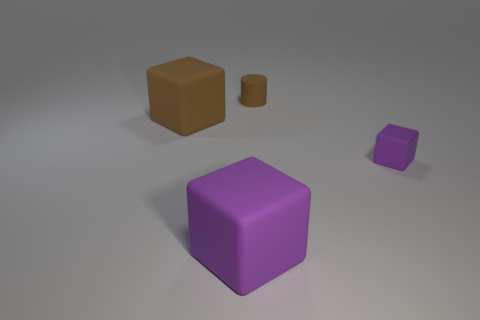What number of purple rubber things are on the left side of the tiny brown rubber cylinder?
Your response must be concise. 1. What number of other things are the same color as the tiny cube?
Offer a terse response. 1. Are there fewer tiny rubber things in front of the large purple object than tiny brown rubber cylinders behind the brown matte block?
Provide a succinct answer. Yes. How many things are either blocks that are right of the small brown thing or big cubes?
Provide a succinct answer. 3. There is a brown matte cylinder; is it the same size as the cube that is in front of the small purple rubber object?
Offer a very short reply. No. What is the size of the other purple rubber object that is the same shape as the tiny purple thing?
Keep it short and to the point. Large. There is a purple block that is on the right side of the purple thing left of the cylinder; how many big brown cubes are in front of it?
Your response must be concise. 0. How many spheres are either big rubber objects or purple things?
Provide a short and direct response. 0. What color is the cube that is behind the tiny matte object that is in front of the brown thing in front of the tiny cylinder?
Keep it short and to the point. Brown. What number of other objects are there of the same size as the brown matte cube?
Your response must be concise. 1. 